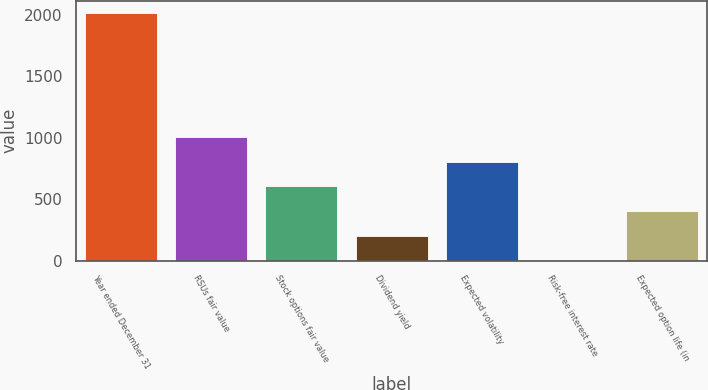<chart> <loc_0><loc_0><loc_500><loc_500><bar_chart><fcel>Year ended December 31<fcel>RSUs fair value<fcel>Stock options fair value<fcel>Dividend yield<fcel>Expected volatility<fcel>Risk-free interest rate<fcel>Expected option life (in<nl><fcel>2013<fcel>1007.15<fcel>604.81<fcel>202.47<fcel>805.98<fcel>1.3<fcel>403.64<nl></chart> 